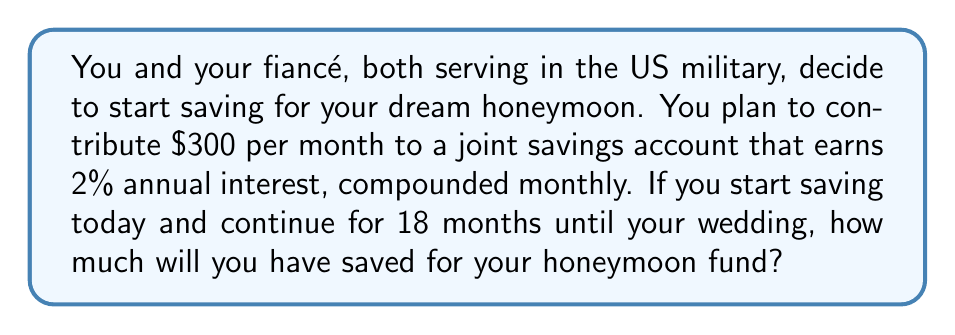Can you answer this question? Let's approach this step-by-step using the compound interest formula for regular contributions:

1) The formula for the future value of regular payments is:

   $$A = P \cdot \frac{(1 + r)^n - 1}{r}$$

   Where:
   $A$ = final amount
   $P$ = monthly contribution
   $r$ = monthly interest rate
   $n$ = number of months

2) Given:
   $P = $300$
   Annual interest rate = 2% = 0.02
   $r = \frac{0.02}{12} = 0.001667$ (monthly rate)
   $n = 18$ months

3) Plug these values into the formula:

   $$A = 300 \cdot \frac{(1 + 0.001667)^{18} - 1}{0.001667}$$

4) Calculate:
   $$A = 300 \cdot \frac{1.030281 - 1}{0.001667}$$
   $$A = 300 \cdot 18.1633$$
   $$A = 5,448.99$$

5) Round to the nearest cent:
   $A = $5,448.99$

Therefore, after 18 months of saving $300 per month with 2% annual interest compounded monthly, you will have saved $5,448.99 for your honeymoon fund.
Answer: $5,448.99 